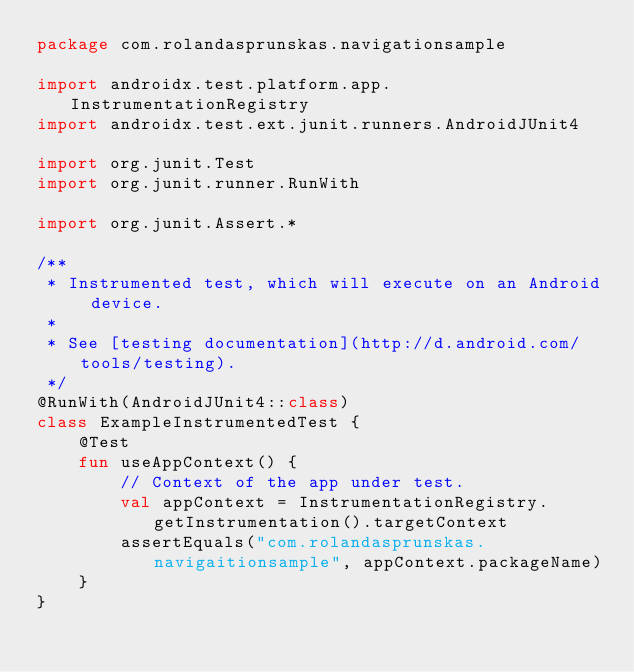<code> <loc_0><loc_0><loc_500><loc_500><_Kotlin_>package com.rolandasprunskas.navigationsample

import androidx.test.platform.app.InstrumentationRegistry
import androidx.test.ext.junit.runners.AndroidJUnit4

import org.junit.Test
import org.junit.runner.RunWith

import org.junit.Assert.*

/**
 * Instrumented test, which will execute on an Android device.
 *
 * See [testing documentation](http://d.android.com/tools/testing).
 */
@RunWith(AndroidJUnit4::class)
class ExampleInstrumentedTest {
    @Test
    fun useAppContext() {
        // Context of the app under test.
        val appContext = InstrumentationRegistry.getInstrumentation().targetContext
        assertEquals("com.rolandasprunskas.navigaitionsample", appContext.packageName)
    }
}</code> 